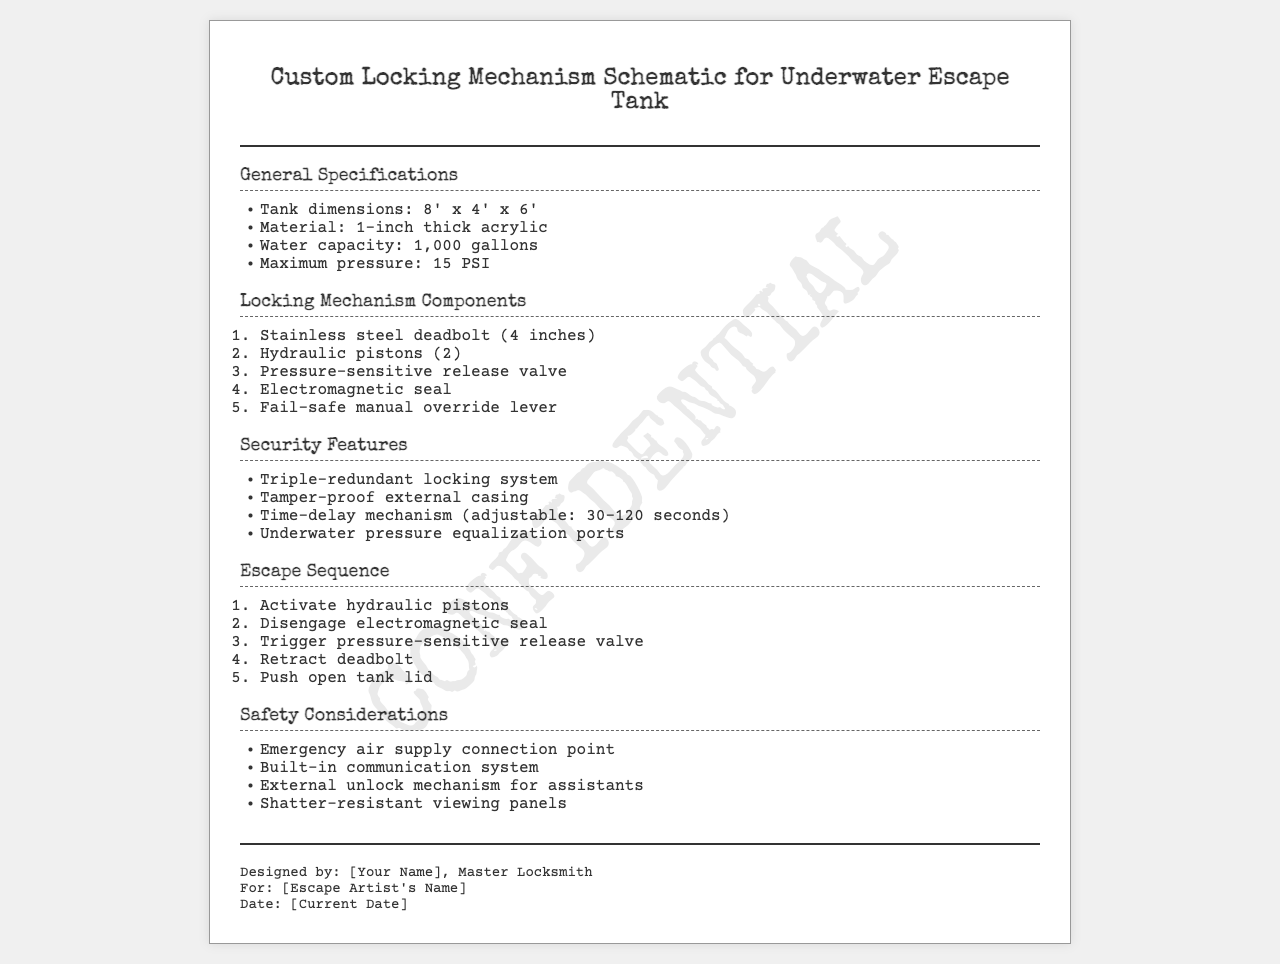what are the dimensions of the tank? The dimensions of the tank are specified in the document as 8 feet by 4 feet by 6 feet.
Answer: 8' x 4' x 6' what is the material of the tank? The document explicitly states that the tank is made from 1-inch thick acrylic.
Answer: 1-inch thick acrylic how many hydraulic pistons are used? The document mentions that there are 2 hydraulic pistons in the locking mechanism.
Answer: 2 what is the adjustable time-delay mechanism range? The time-delay mechanism can be adjusted between 30 to 120 seconds as per the information provided in the document.
Answer: 30-120 seconds what safety feature is related to communication? The document specifies that there is a built-in communication system as a safety consideration.
Answer: built-in communication system how does the escape sequence start? The escape sequence begins with the activation of hydraulic pistons, as detailed in the list.
Answer: Activate hydraulic pistons what type of locking system is employed? The document describes the locking system as being triple-redundant, indicating an advanced level of security.
Answer: Triple-redundant locking system who designed the locking mechanism? The footer of the document identifies the designer as a Master Locksmith, though the specific name is indicated as a placeholder.
Answer: [Your Name] what is the purpose of external unlock mechanism? The document states that the external unlock mechanism is for assistants, indicating its role in assisting with escapes.
Answer: for assistants 